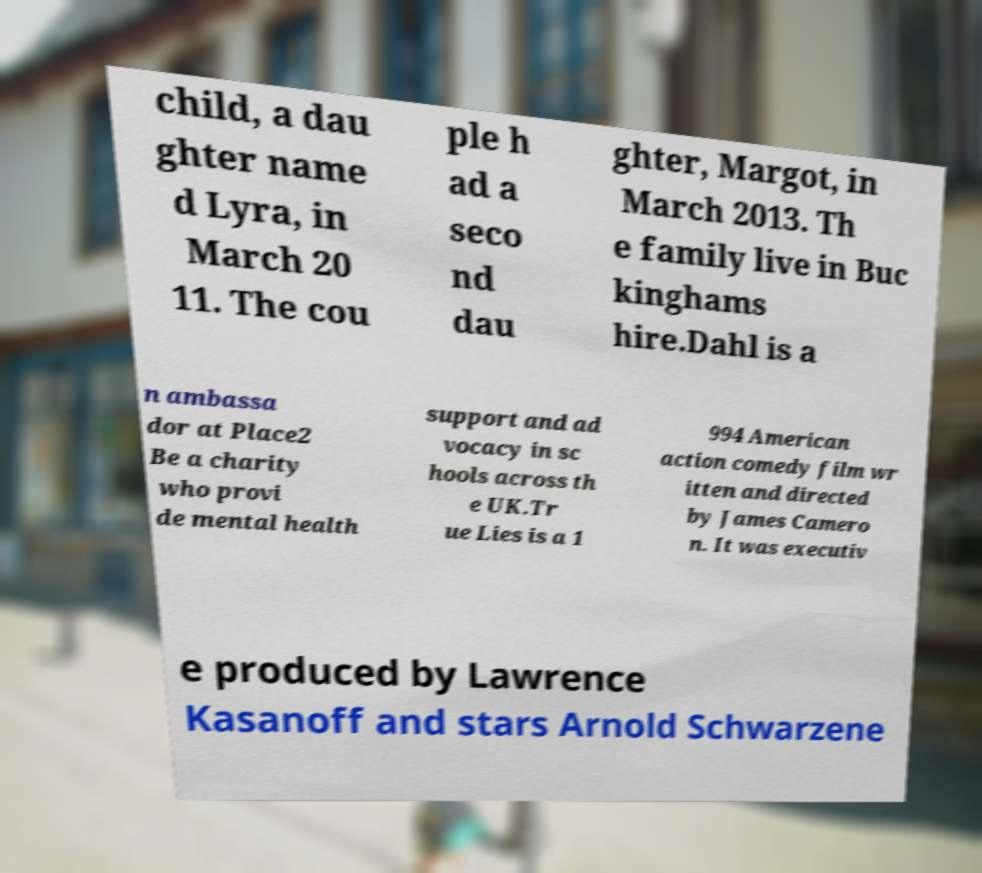There's text embedded in this image that I need extracted. Can you transcribe it verbatim? child, a dau ghter name d Lyra, in March 20 11. The cou ple h ad a seco nd dau ghter, Margot, in March 2013. Th e family live in Buc kinghams hire.Dahl is a n ambassa dor at Place2 Be a charity who provi de mental health support and ad vocacy in sc hools across th e UK.Tr ue Lies is a 1 994 American action comedy film wr itten and directed by James Camero n. It was executiv e produced by Lawrence Kasanoff and stars Arnold Schwarzene 